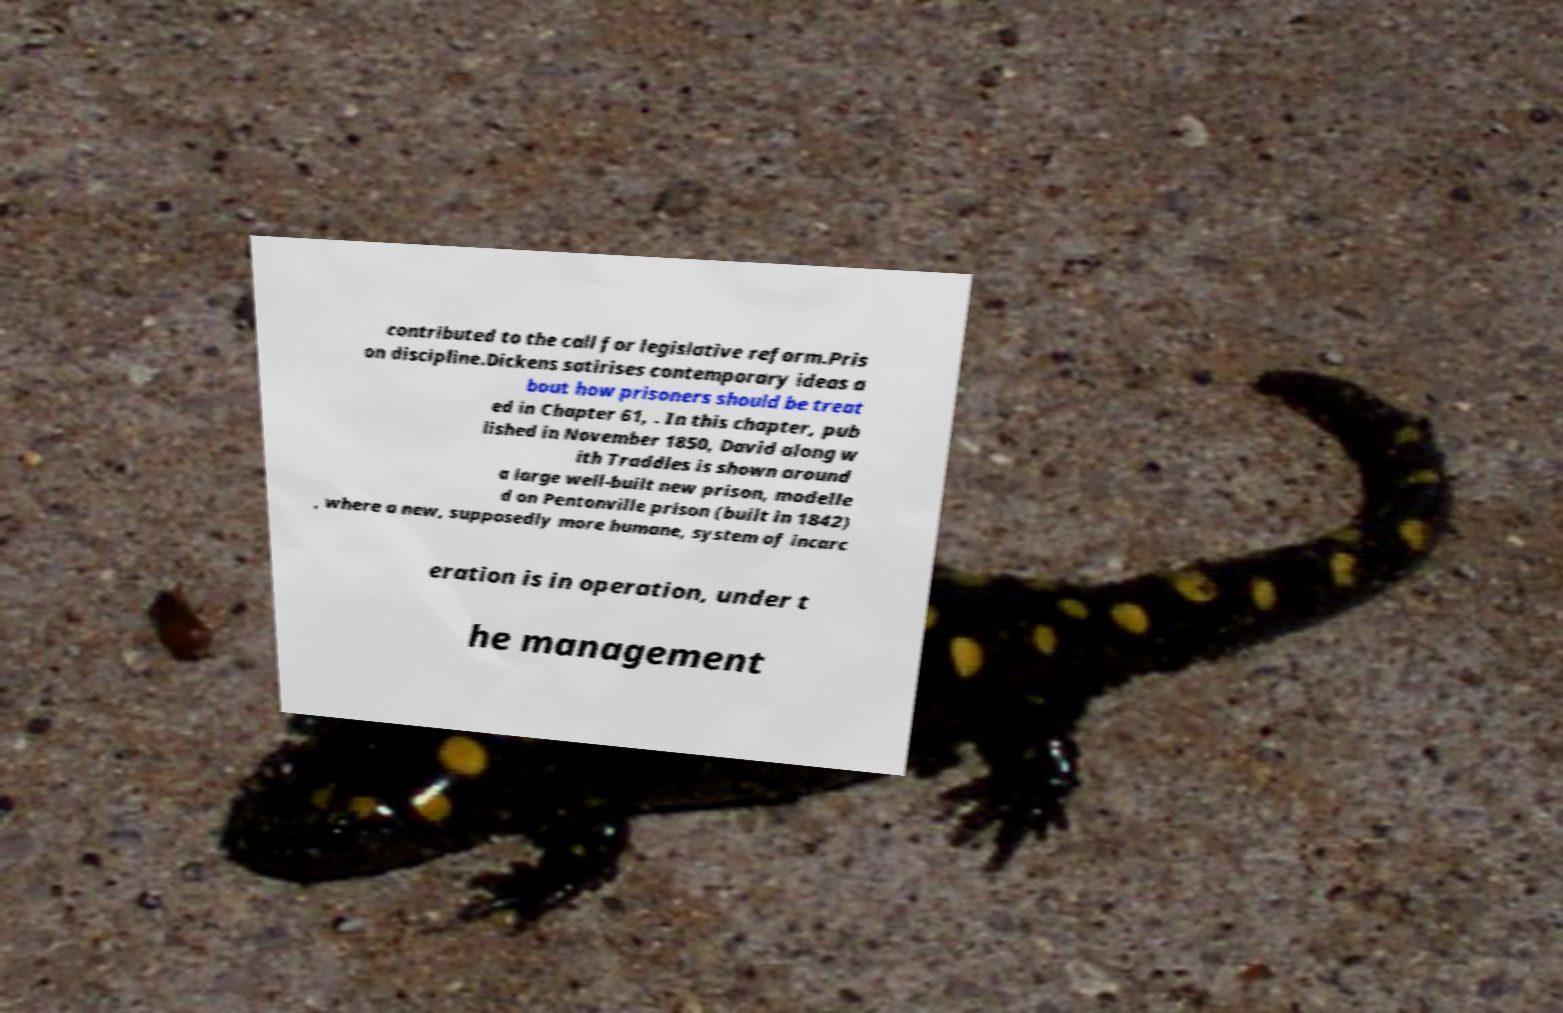I need the written content from this picture converted into text. Can you do that? contributed to the call for legislative reform.Pris on discipline.Dickens satirises contemporary ideas a bout how prisoners should be treat ed in Chapter 61, . In this chapter, pub lished in November 1850, David along w ith Traddles is shown around a large well-built new prison, modelle d on Pentonville prison (built in 1842) , where a new, supposedly more humane, system of incarc eration is in operation, under t he management 